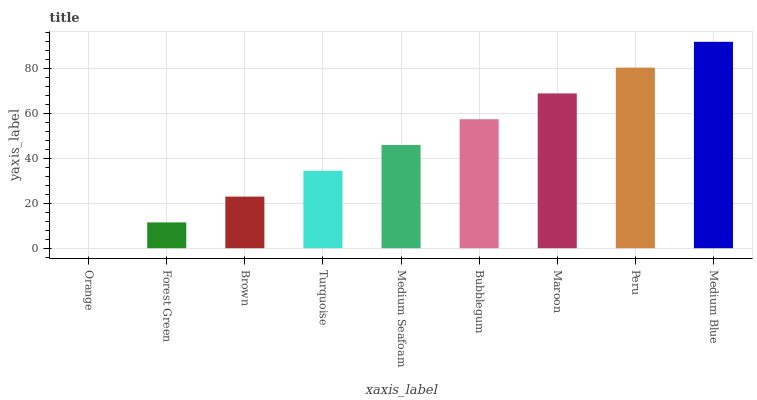Is Orange the minimum?
Answer yes or no. Yes. Is Medium Blue the maximum?
Answer yes or no. Yes. Is Forest Green the minimum?
Answer yes or no. No. Is Forest Green the maximum?
Answer yes or no. No. Is Forest Green greater than Orange?
Answer yes or no. Yes. Is Orange less than Forest Green?
Answer yes or no. Yes. Is Orange greater than Forest Green?
Answer yes or no. No. Is Forest Green less than Orange?
Answer yes or no. No. Is Medium Seafoam the high median?
Answer yes or no. Yes. Is Medium Seafoam the low median?
Answer yes or no. Yes. Is Turquoise the high median?
Answer yes or no. No. Is Turquoise the low median?
Answer yes or no. No. 